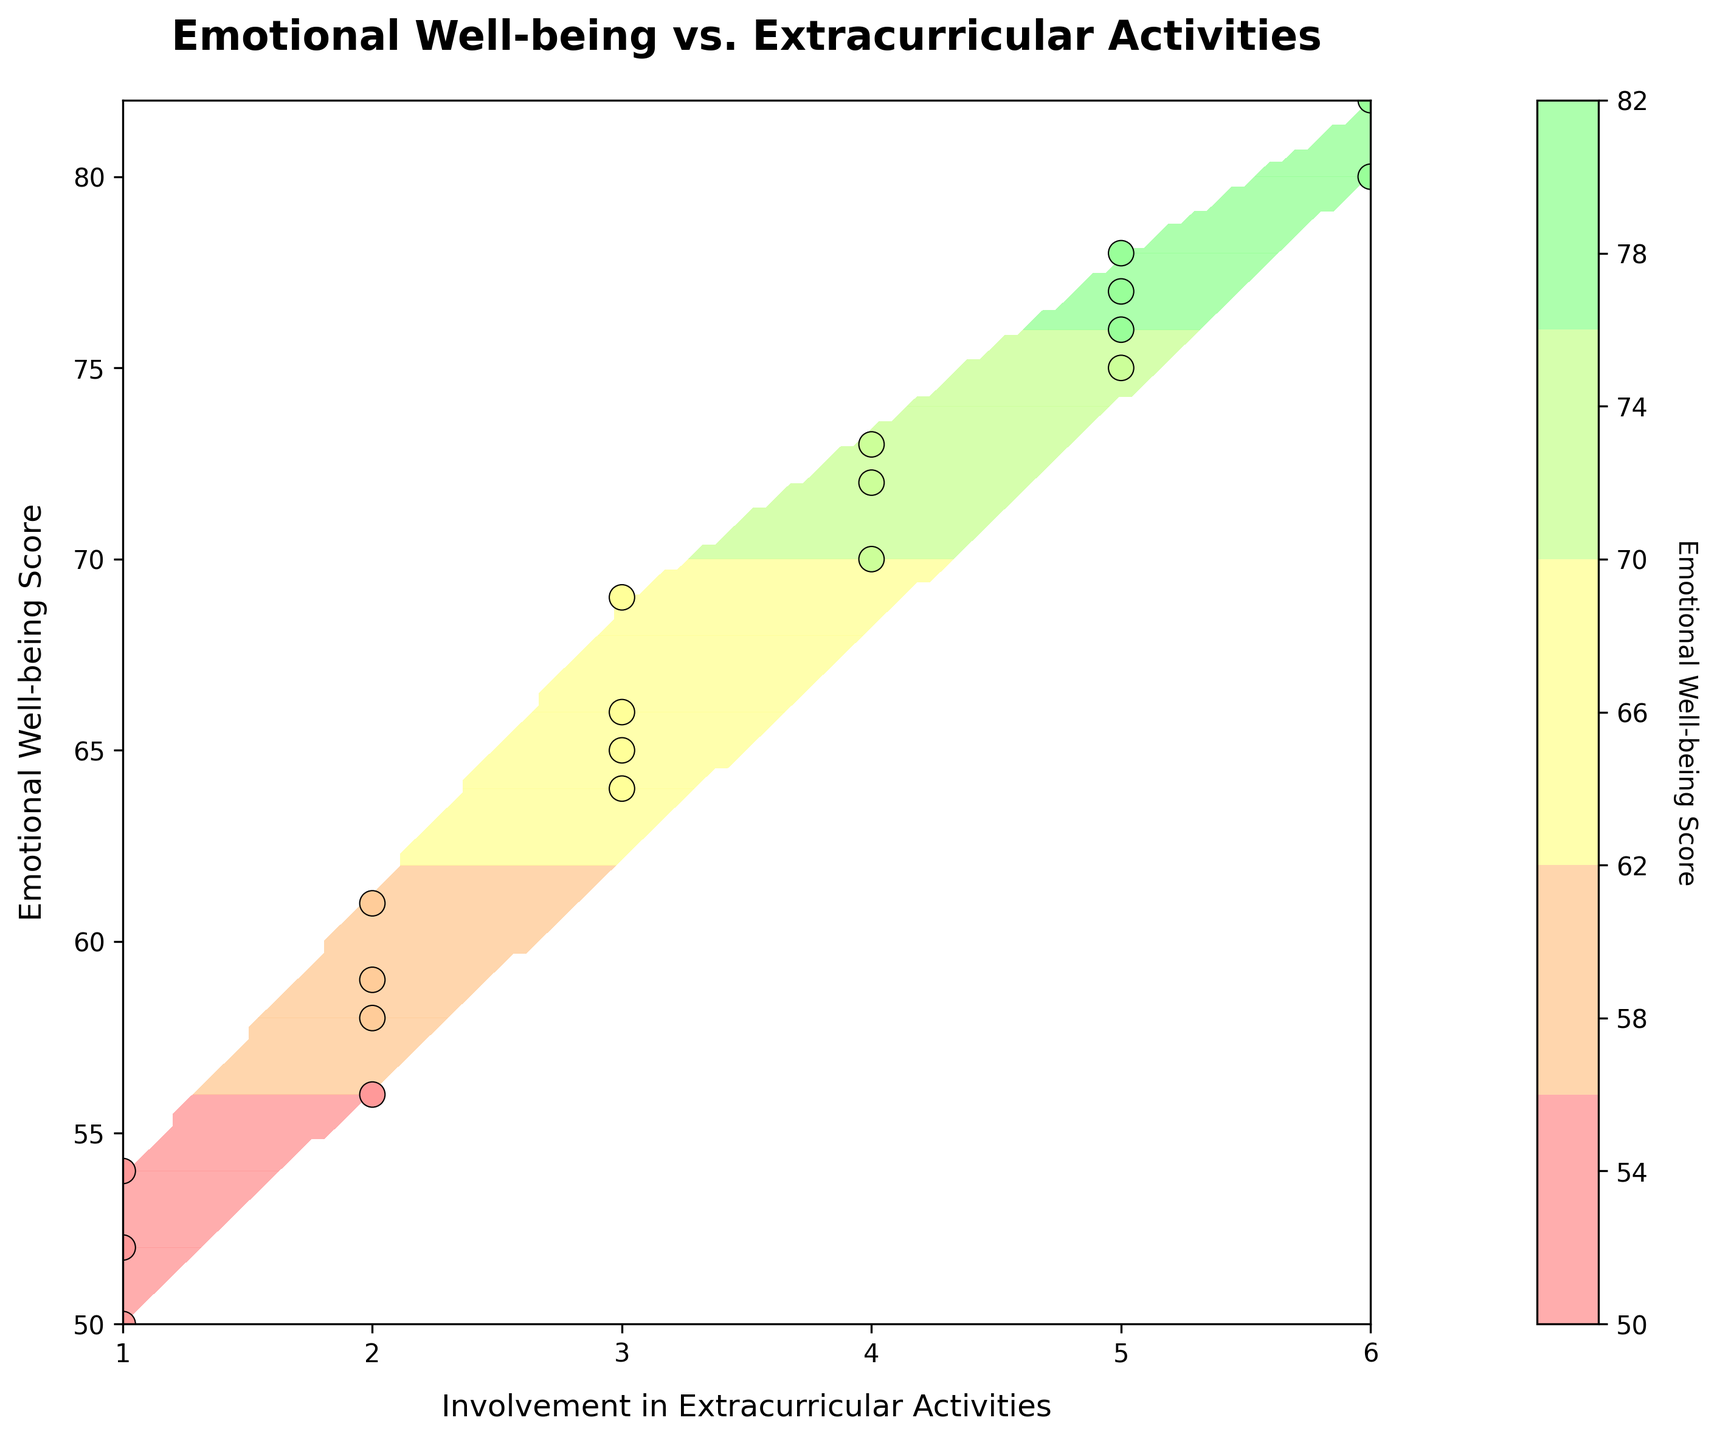How many data points are shown in the figure? To determine the number of data points, we visually count the scatter points present on the contour plot. Each scatter point represents a student's data.
Answer: 19 What is the title of the figure? The title is the text located at the top of the figure. It typically describes what the entire plot represents.
Answer: Emotional Well-being vs. Extracurricular Activities What are the axis labels? Axis labels describe what is plotted on each axis. They are usually located next to or below the axes.
Answer: Involvement in Extracurricular Activities (x-axis) and Emotional Well-being Score (y-axis) How many levels of contour lines are there in the plot? To find the number of contour levels, count the distinct shaded regions or lines in the contour plot, each representing a different range of values.
Answer: 20 What is the color representing the highest Emotional Well-being Scores on the contour plot? Identify the color associated with the highest values in the color bar legend, which maps different colors to different score ranges.
Answer: Green Which student had the highest Emotional Well-being Score and how involved were they in extracurricular activities? Look for the highest data point on the y-axis of the scatter plot, and then trace its corresponding x-axis value to identify the student's involvement level.
Answer: Lucas, 6 How does the Emotional Well-being Score change with increasing involvement from level 1 to level 6? Trace the average trend of the contour lines from left (1) to right (6) and observe the general slope. As the involvement increases, check how the scores on the y-axis move.
Answer: Well-being tends to increase with involvement Which two students with the same level of involvement in extracurricular activities have the closest Emotional Well-being Scores? For each level of involvement, identify the pair of data points and compare their y-axis values, noting which pairs are the closest.
Answer: Jacob and James (Involvement level 2) Is there a general trend visible between involvement in extracurricular activities and Emotional Well-being Scores? Examine the overall pattern of the contour lines and scatter points. Check if there's an upward, downward, or no visible trend as the x-axis values increase.
Answer: Increasing trend 